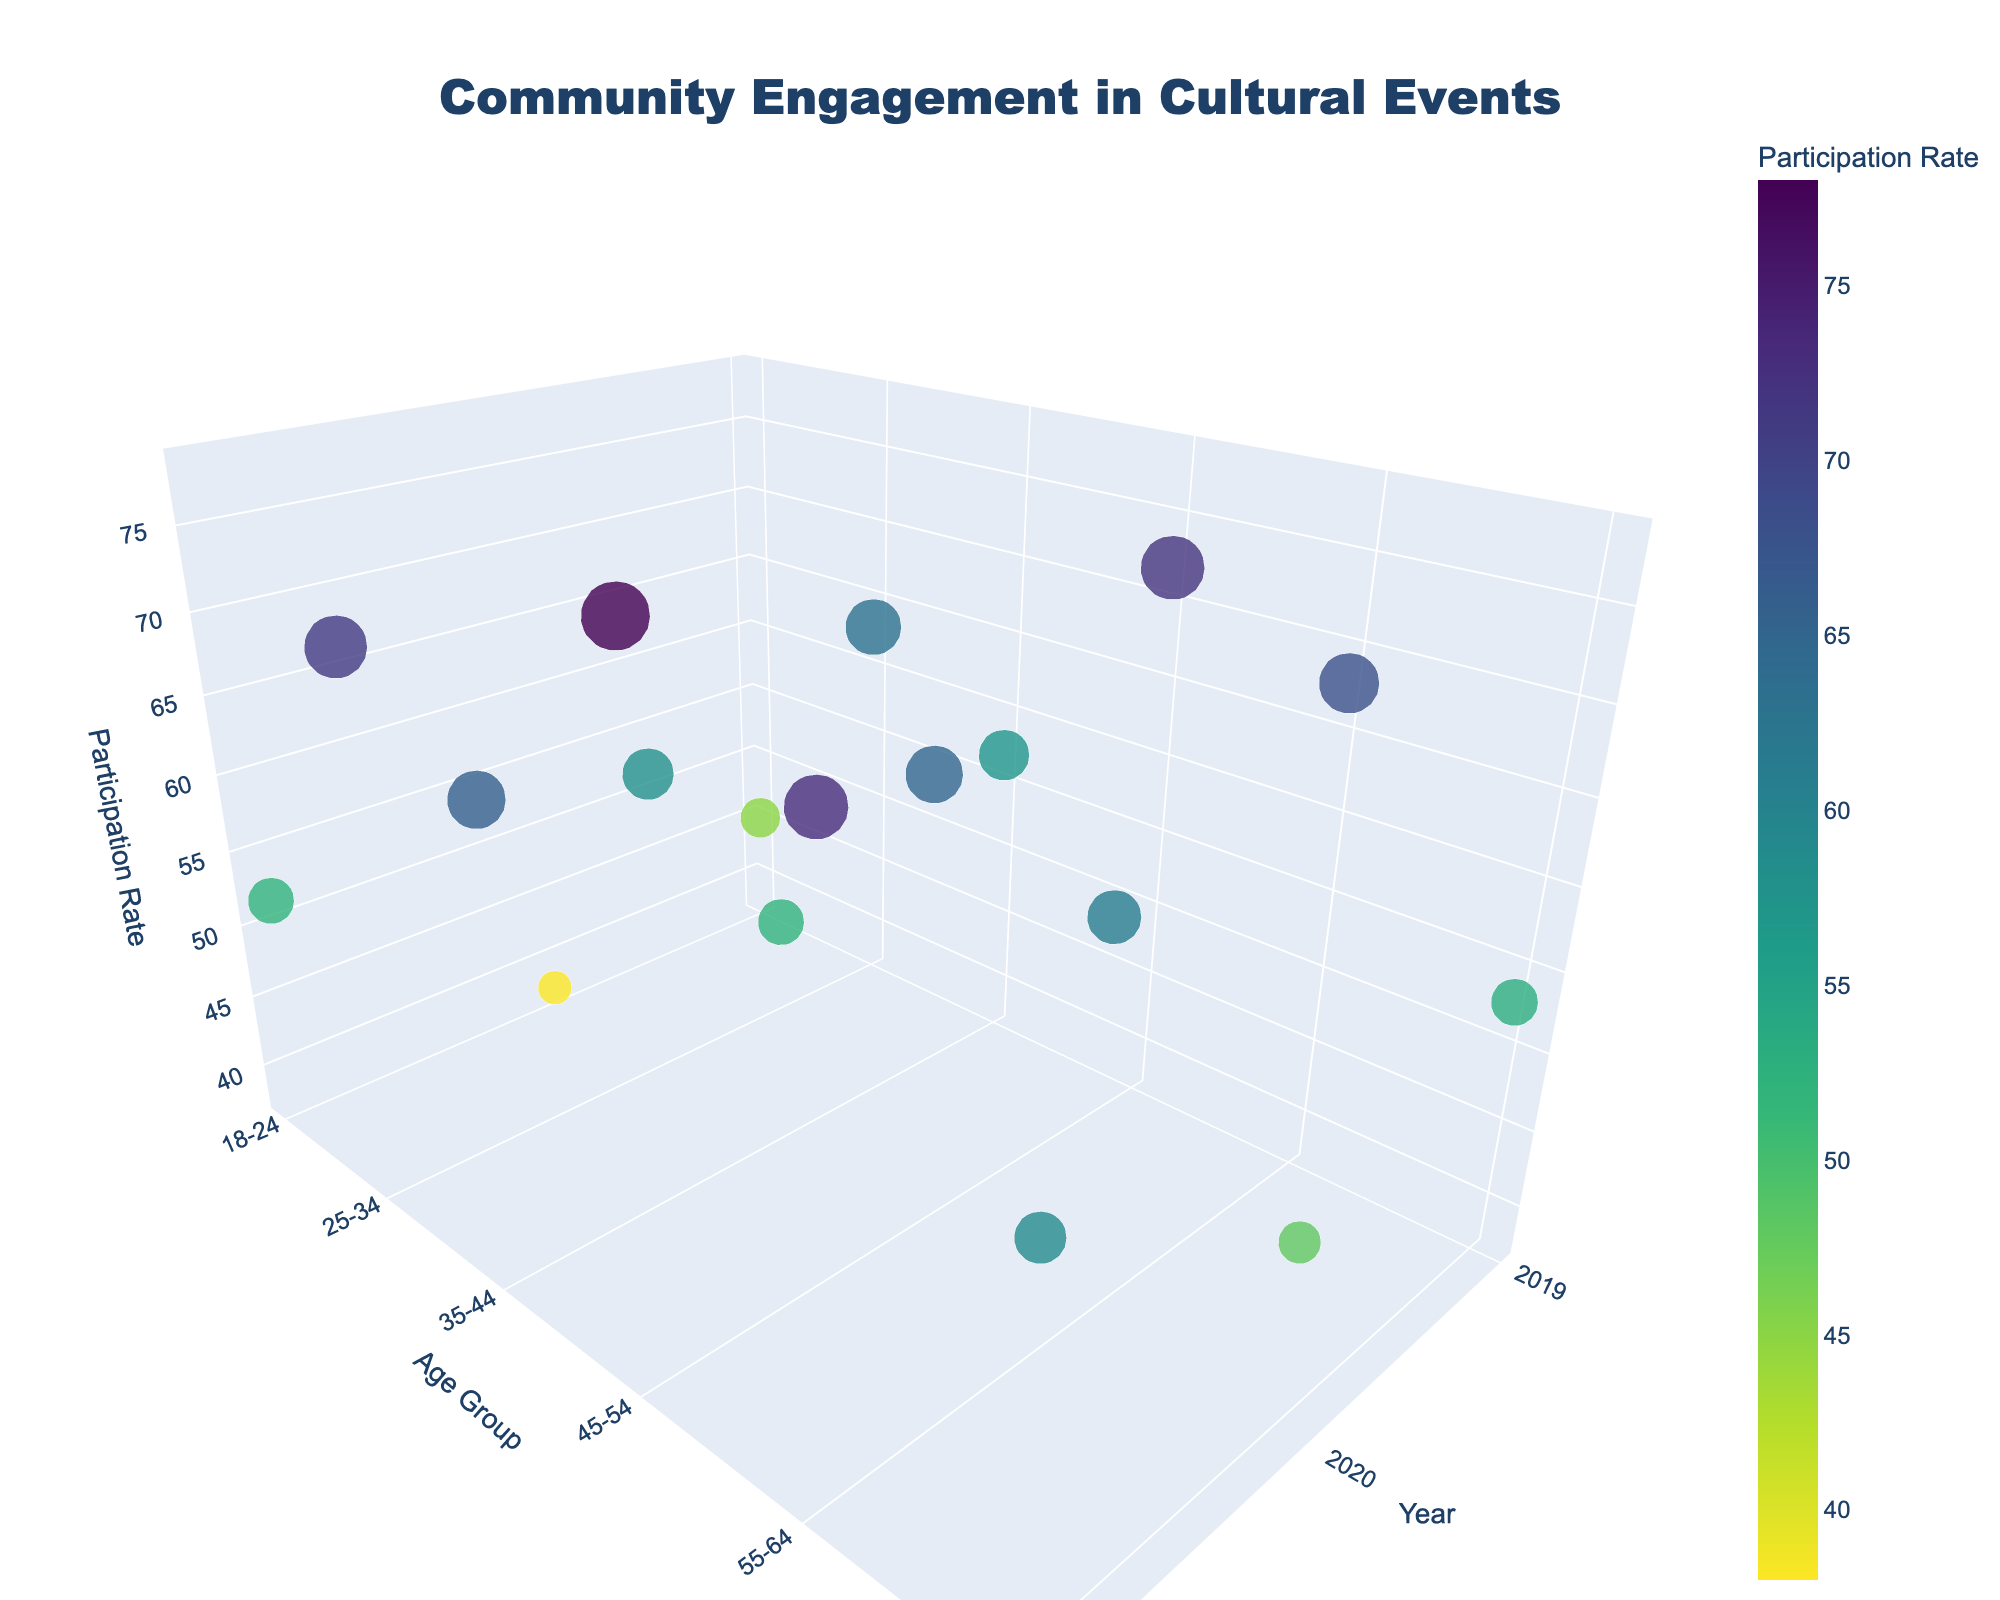What is the title of the 3D plot? The title of the plot is usually displayed prominently at the top. By looking at the top of the plot, we can see the title.
Answer: Community Engagement in Cultural Events What are the labels of the three axes in the figure? The axes labels are typically shown along the edges of the 3D plot for each axis. By examining the plot, you can identify the labels.
Answer: Year, Age Group, Participation Rate Which age group had the highest participation in 2019? We need to look at the Year axis for 2019 and then identify which data point in 2019 has the highest value on the Participation Rate axis.
Answer: 45-54 What is the participation rate for the 'Ethnic Dance Competition' in 2021 for the 25-34 age group? Locate the 25-34 age group and the year 2021 on the axes. Find the corresponding data point and check the Participation Rate value.
Answer: 71 Compare the participation rates in 2020 for the age groups 35-44 and 55-64. Which age group had a higher participation rate? We need to look at the year 2020 data points for the age groups 35-44 and 55-64, then compare their Participation Rates.
Answer: 35-44 Which event had the lowest participation rate in 2020? For the year 2020, examine all the data points and find the one with the smallest Participation Rate. Check the Event Type for this data point.
Answer: Intergenerational Cultural Exchange How does the participation rate for the 65+ age group change from 2019 to 2021? Identify the data points for the 65+ age group for the years 2019, 2020, and 2021. Compare the Participation Rates across these years.
Answer: It decreases from 53 in 2019 to 48 in 2020, then increases to 59 in 2021 Which event type had the highest participation rate in 2021, and in which age group was it? Find the data point with the highest Participation Rate for the year 2021. Check the Event Type and the Age Group corresponding to this data point.
Answer: Cultural Fashion Show, 45-54 How many data points are there for each year on the plot? Count the number of data points corresponding to each year on the Year axis.
Answer: 6 per year What is the average participation rate for the age group 18-24 across all years? Identify the participation rates for the 18-24 age group for all years (2019, 2020, 2021), sum them up and divide by the number of data points (3) to find the average.
Answer: (45 + 38 + 52) / 3 = 45 